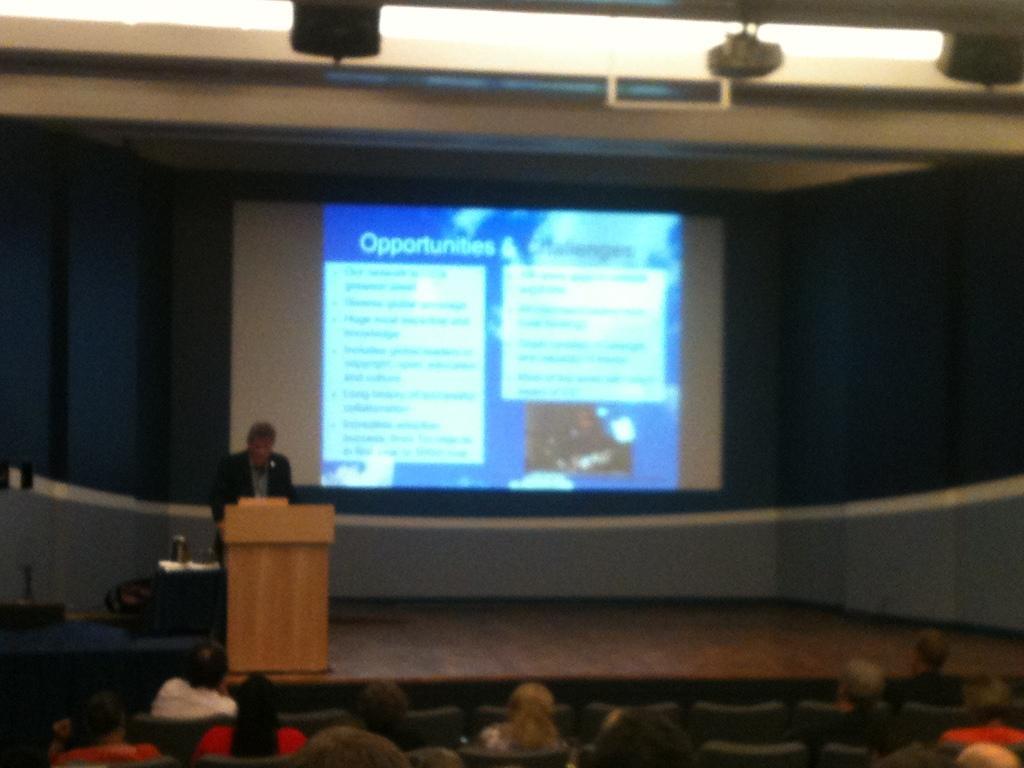How would you summarize this image in a sentence or two? In this image, there are a few people. Among them, some people are sitting and a person is standing on the stage. We can also see the podium and the stage with some objects. We can see the projector screen and some objects at the top. We can also see some chairs. 